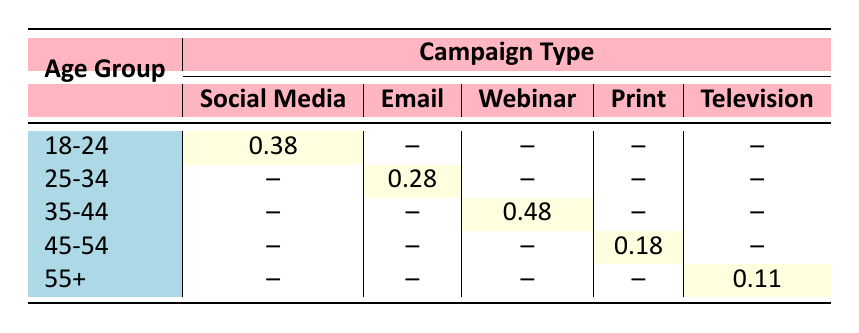What is the response rate for the Social Media campaign among the 18-24 age group? The table shows the response rate for each campaign type and age group. For the age group 18-24 under Social Media, the response rate is directly indicated as 0.35.
Answer: 0.35 Which campaign type had the highest response rate in the 35-44 age group? In the table, for the 35-44 age group, there are three entries listed: Email, Webinar, and Print. The Webinar campaign shows the highest response rate of 0.45.
Answer: Webinar Is the response rate for the Print campaign higher for males or females in the 45-54 age group? The response rate for males in the Print campaign (0.20) is compared to that of females (0.15). Since 0.20 is greater than 0.15, the response rate for males is higher.
Answer: Yes What is the average response rate for the Social Media campaign across all age groups listed? The Social Media campaign response rates for different age groups are: 0.35 (18-24) and 0.40 (18-24, Female). Adding these gives a total of 0.75, and dividing by 2 (the number of entries) gives an average of 0.375.
Answer: 0.375 How does the response rate for the Television campaign compare between the 55+ males and females? The Television campaign shows a response rate of 0.10 for males and 0.12 for females in the 55+ age group. Since 0.12 is greater than 0.10, females have a higher response rate than males.
Answer: Yes What is the difference in the response rates between the Email campaigns for the 25-34 age group males and females? The response rate for males in the Email campaign is 0.30, while for females it is 0.25. The difference is calculated by subtracting 0.25 from 0.30, which results in a difference of 0.05.
Answer: 0.05 Does the 45-54 age group have any Social Media campaign response rate listed? By checking the table, there are no entries listed for the Social Media campaign under the 45-54 age group. Thus, this fact can be determined easily from the data.
Answer: No Which gender had a better response rate for the Webinar campaign in the 35-44 age group? The response rate for males is 0.45, while for females it is 0.50, indicating that the females had a better response rate.
Answer: Female 